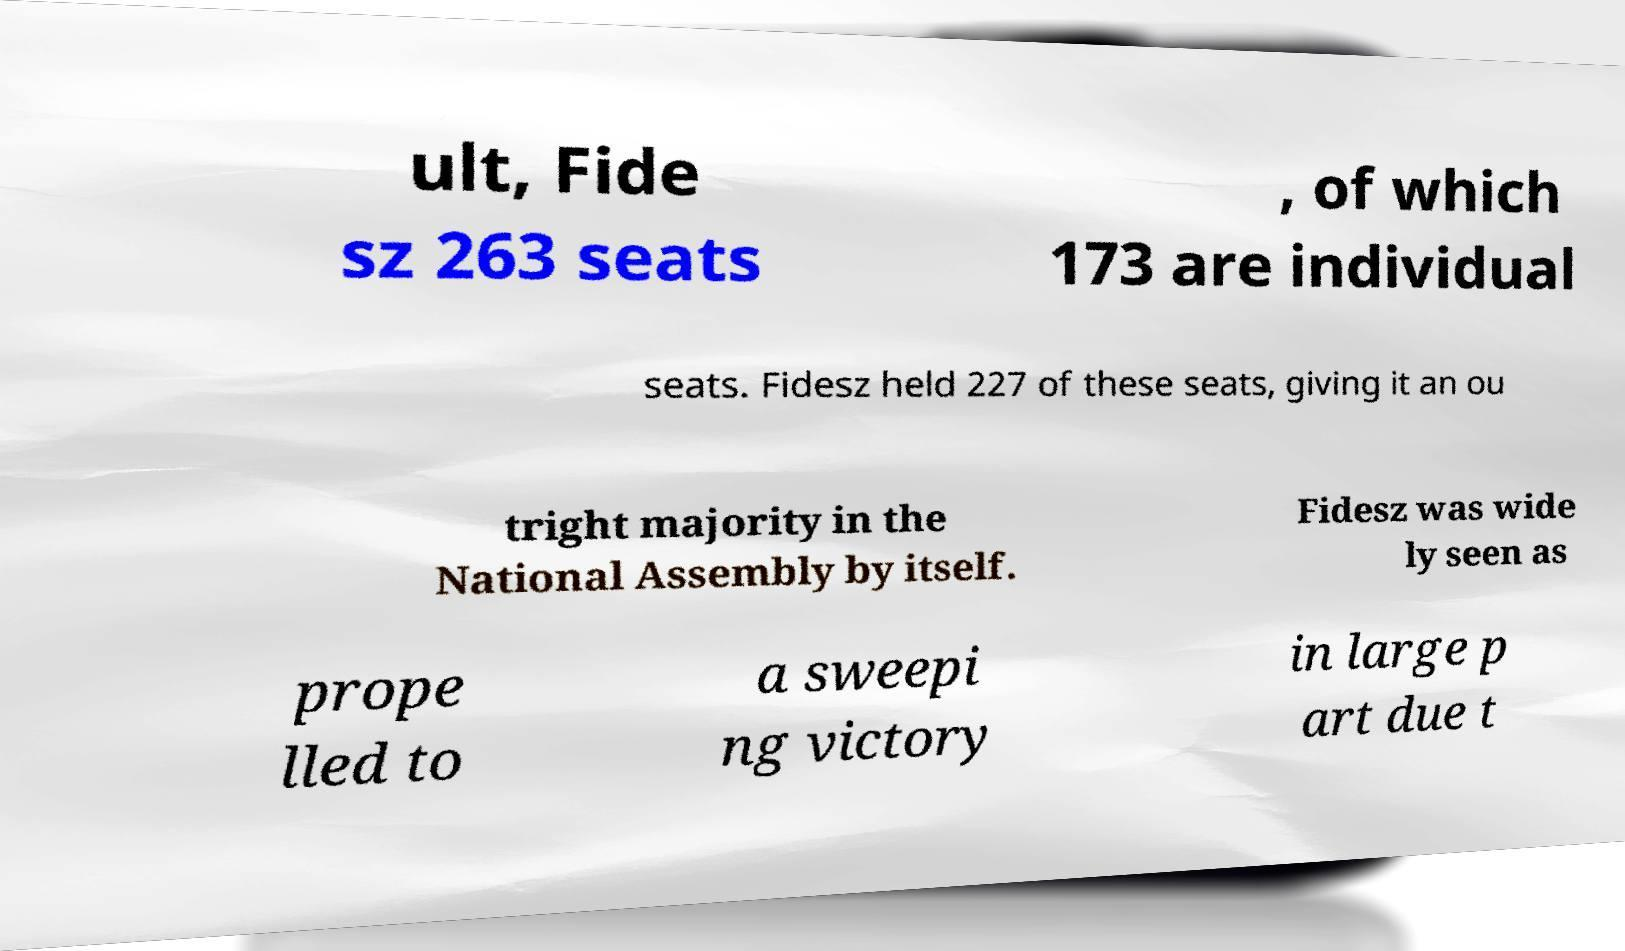What messages or text are displayed in this image? I need them in a readable, typed format. ult, Fide sz 263 seats , of which 173 are individual seats. Fidesz held 227 of these seats, giving it an ou tright majority in the National Assembly by itself. Fidesz was wide ly seen as prope lled to a sweepi ng victory in large p art due t 